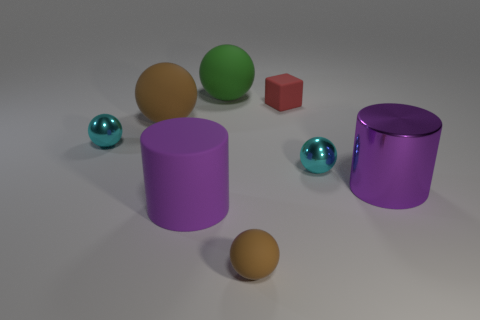Subtract 2 balls. How many balls are left? 3 Subtract all green spheres. How many spheres are left? 4 Subtract all big brown rubber spheres. How many spheres are left? 4 Add 1 large green matte objects. How many objects exist? 9 Subtract all yellow balls. Subtract all purple cubes. How many balls are left? 5 Subtract 0 yellow cylinders. How many objects are left? 8 Subtract all cylinders. How many objects are left? 6 Subtract all big cyan balls. Subtract all small red matte objects. How many objects are left? 7 Add 5 large rubber balls. How many large rubber balls are left? 7 Add 4 matte cylinders. How many matte cylinders exist? 5 